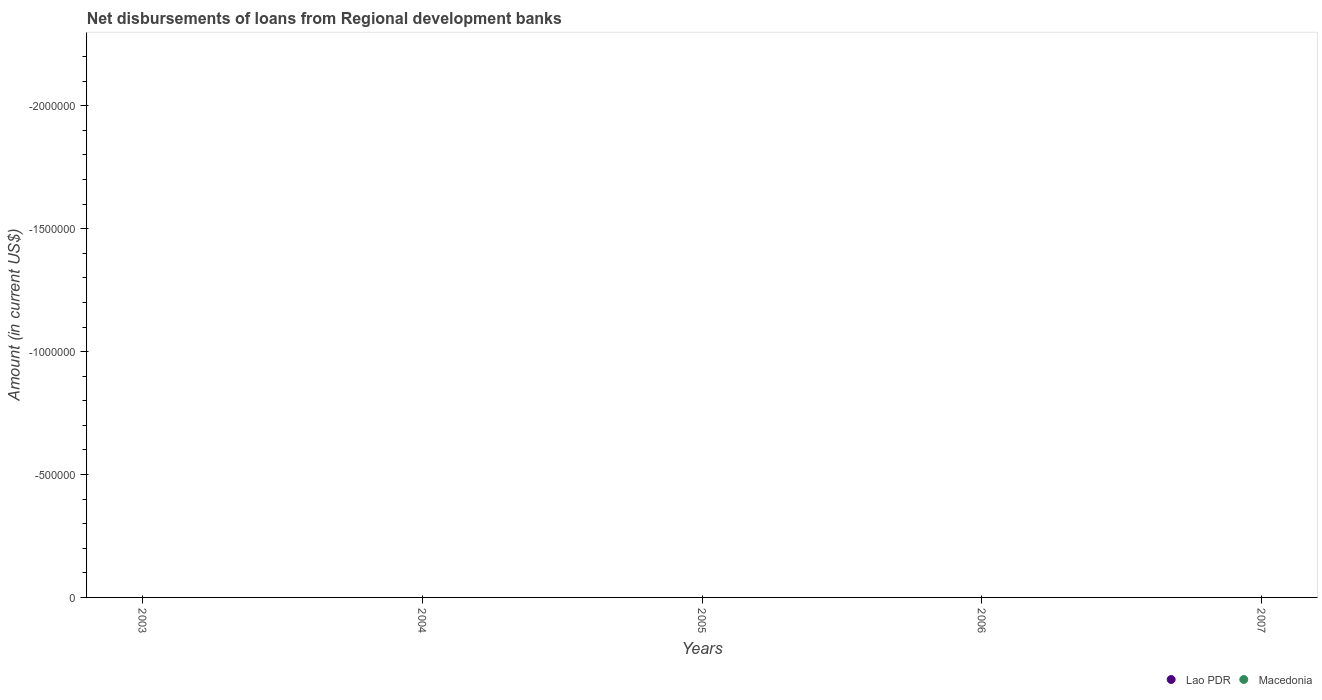How many different coloured dotlines are there?
Your response must be concise. 0. Across all years, what is the minimum amount of disbursements of loans from regional development banks in Lao PDR?
Your response must be concise. 0. What is the difference between the amount of disbursements of loans from regional development banks in Lao PDR in 2003 and the amount of disbursements of loans from regional development banks in Macedonia in 2005?
Ensure brevity in your answer.  0. What is the average amount of disbursements of loans from regional development banks in Lao PDR per year?
Make the answer very short. 0. In how many years, is the amount of disbursements of loans from regional development banks in Macedonia greater than -1700000 US$?
Provide a succinct answer. 0. In how many years, is the amount of disbursements of loans from regional development banks in Lao PDR greater than the average amount of disbursements of loans from regional development banks in Lao PDR taken over all years?
Your answer should be compact. 0. Is the amount of disbursements of loans from regional development banks in Lao PDR strictly greater than the amount of disbursements of loans from regional development banks in Macedonia over the years?
Offer a very short reply. Yes. Is the amount of disbursements of loans from regional development banks in Macedonia strictly less than the amount of disbursements of loans from regional development banks in Lao PDR over the years?
Ensure brevity in your answer.  Yes. Does the graph contain any zero values?
Your response must be concise. Yes. Where does the legend appear in the graph?
Provide a short and direct response. Bottom right. How many legend labels are there?
Offer a terse response. 2. What is the title of the graph?
Your answer should be very brief. Net disbursements of loans from Regional development banks. What is the label or title of the Y-axis?
Offer a very short reply. Amount (in current US$). What is the Amount (in current US$) in Macedonia in 2003?
Your answer should be compact. 0. What is the Amount (in current US$) in Lao PDR in 2004?
Your response must be concise. 0. What is the Amount (in current US$) of Macedonia in 2004?
Make the answer very short. 0. What is the Amount (in current US$) in Lao PDR in 2005?
Ensure brevity in your answer.  0. What is the Amount (in current US$) in Macedonia in 2005?
Offer a very short reply. 0. What is the Amount (in current US$) in Lao PDR in 2007?
Your response must be concise. 0. What is the Amount (in current US$) in Macedonia in 2007?
Keep it short and to the point. 0. What is the average Amount (in current US$) in Lao PDR per year?
Your answer should be very brief. 0. 